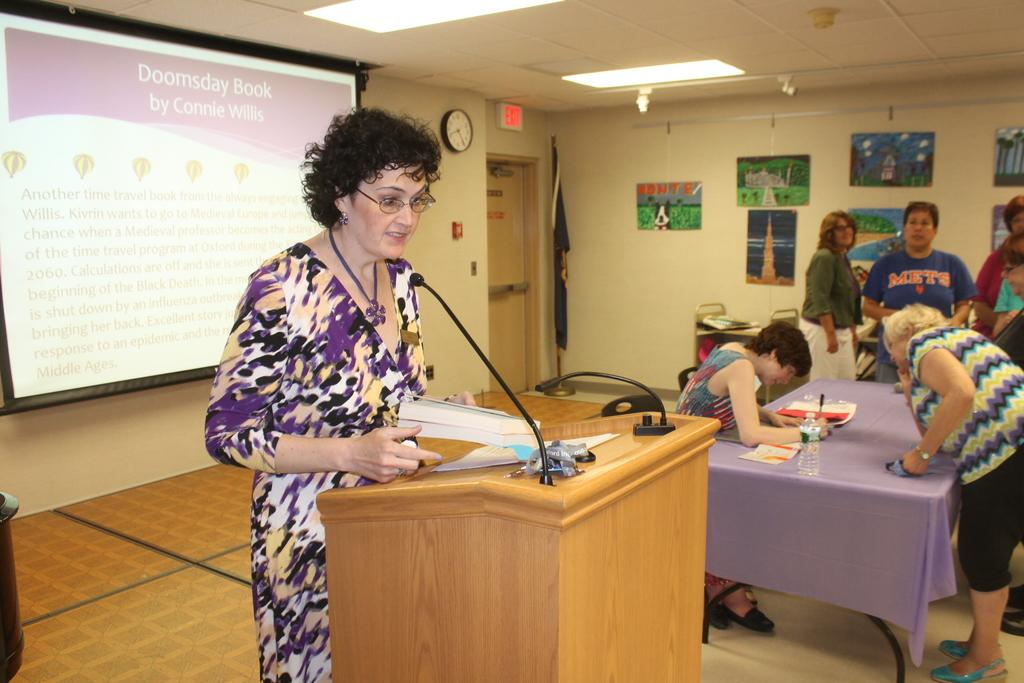What type of structure can be seen in the image? There is a wall in the image. Is there any entrance visible in the image? Yes, there is a door in the image. What time-related object is present in the image? There is a clock in the image. Are there any decorative items in the image? Yes, there are photo frames in the image. What type of display device is present in the image? There is a screen in the image. Are there any people in the image? Yes, there are people in the image. What piece of furniture is present in the image? There is a table in the image. What is on the table in the image? There is a bottle and papers on the table. How many icicles are hanging from the door in the image? There are no icicles present in the image. What type of hand is shown holding the bottle on the table? There are no hands visible in the image; only the bottle and papers are present on the table. 